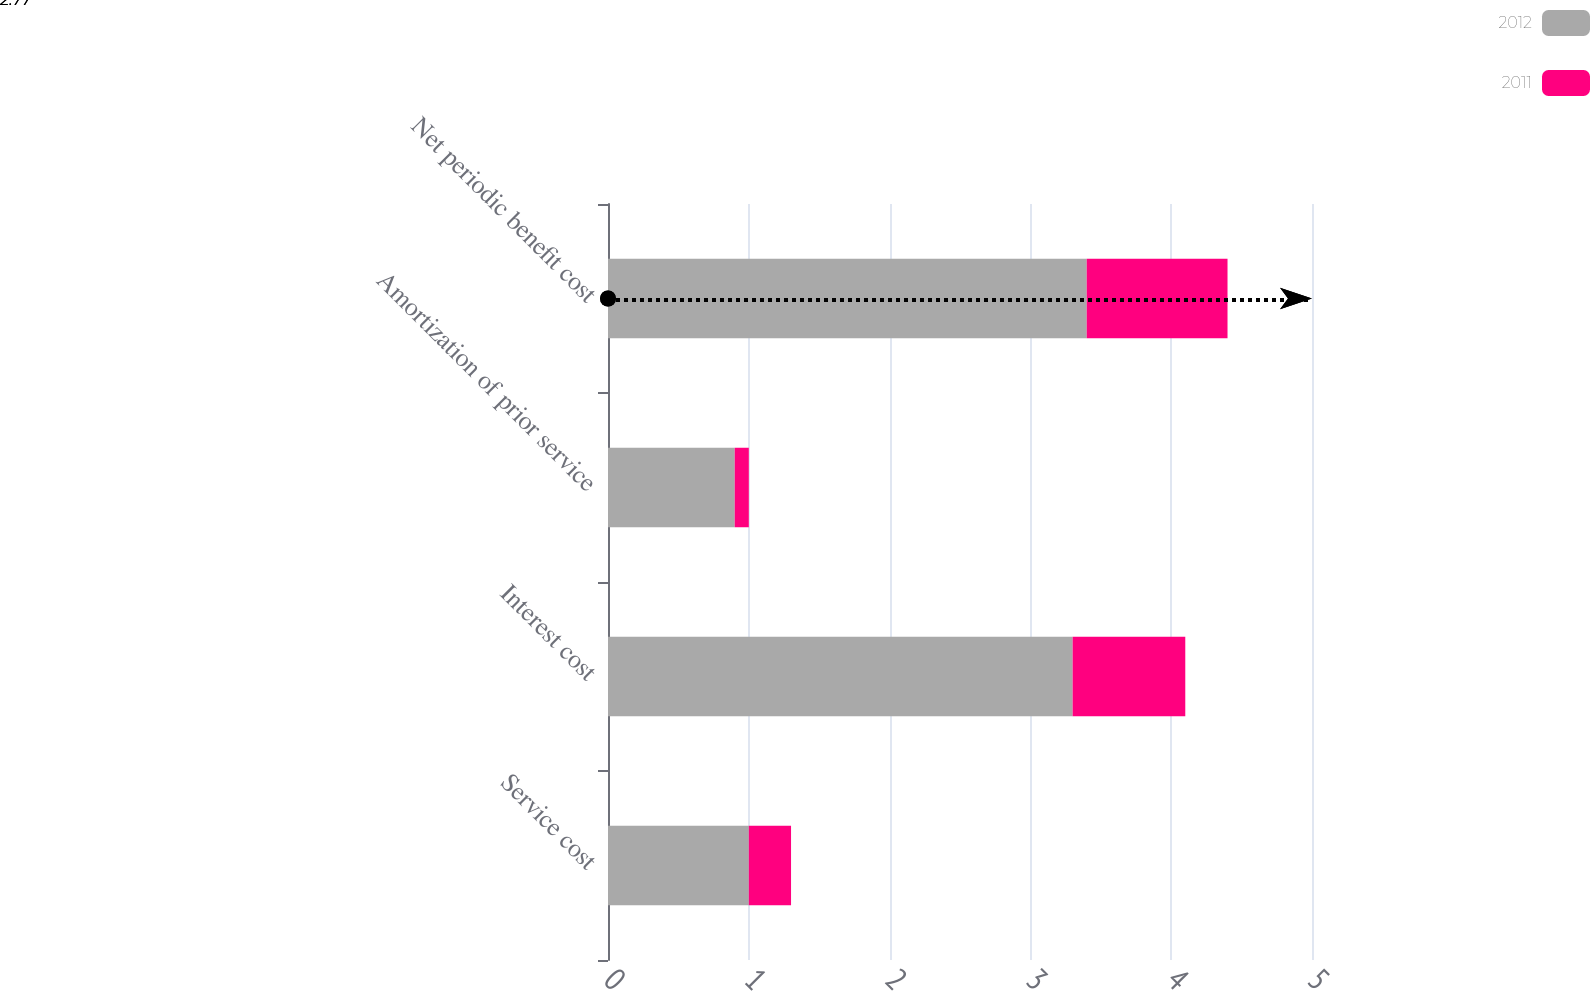Convert chart to OTSL. <chart><loc_0><loc_0><loc_500><loc_500><stacked_bar_chart><ecel><fcel>Service cost<fcel>Interest cost<fcel>Amortization of prior service<fcel>Net periodic benefit cost<nl><fcel>2012<fcel>1<fcel>3.3<fcel>0.9<fcel>3.4<nl><fcel>2011<fcel>0.3<fcel>0.8<fcel>0.1<fcel>1<nl></chart> 